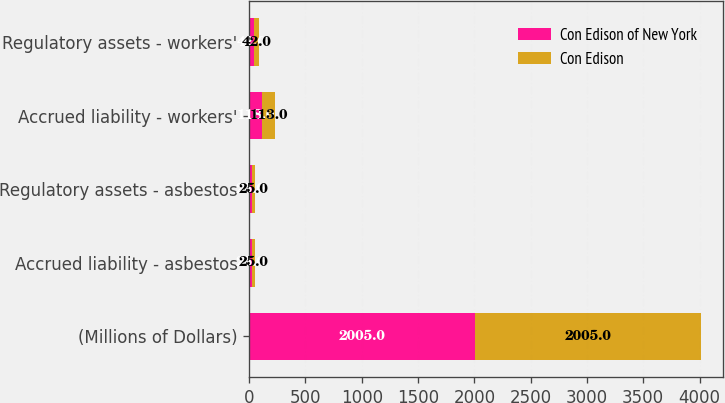<chart> <loc_0><loc_0><loc_500><loc_500><stacked_bar_chart><ecel><fcel>(Millions of Dollars)<fcel>Accrued liability - asbestos<fcel>Regulatory assets - asbestos<fcel>Accrued liability - workers'<fcel>Regulatory assets - workers'<nl><fcel>Con Edison of New York<fcel>2005<fcel>25<fcel>25<fcel>118<fcel>42<nl><fcel>Con Edison<fcel>2005<fcel>25<fcel>25<fcel>113<fcel>42<nl></chart> 